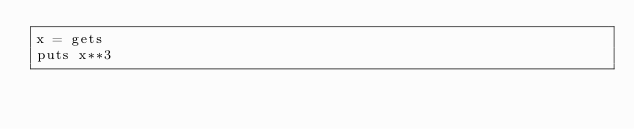<code> <loc_0><loc_0><loc_500><loc_500><_Ruby_>x = gets
puts x**3</code> 